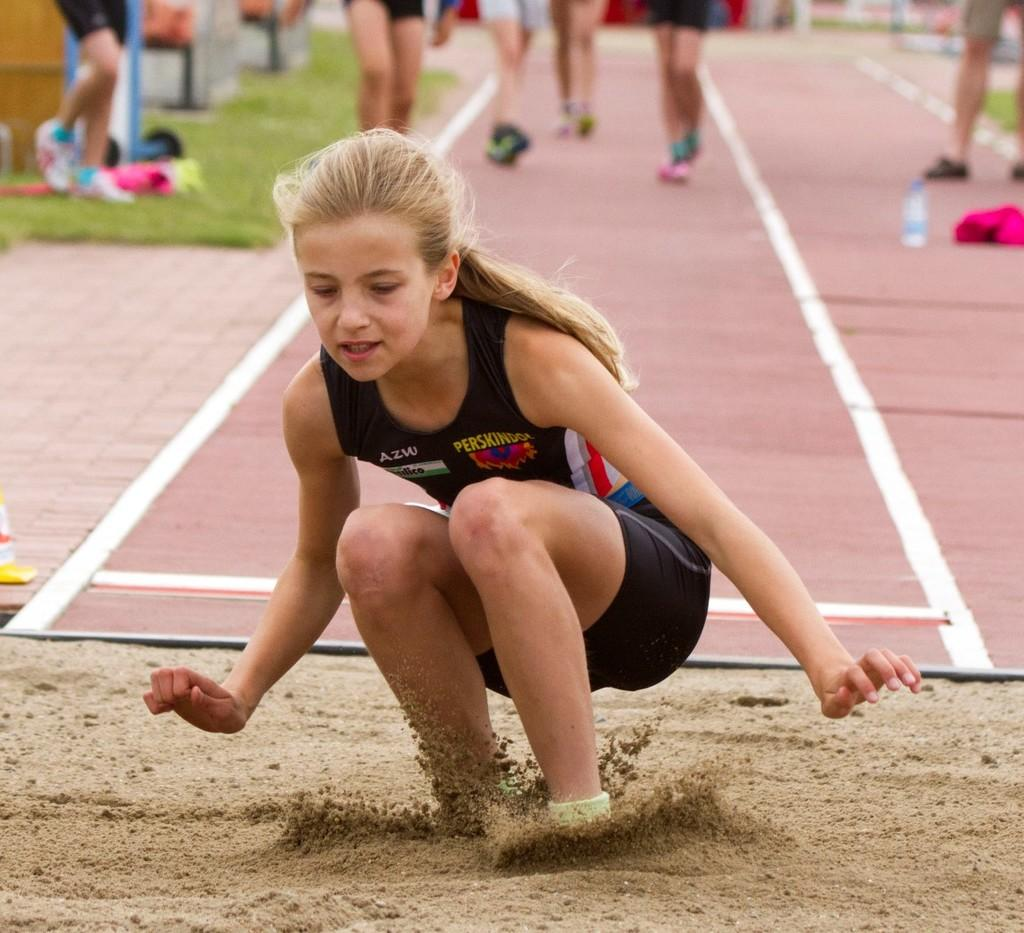What type of surface can be seen in the image? There is green grass and sand visible in the image. What objects can be seen in the image? There is a water bottle and other unspecified objects in the image. What is the position of the girl in the image? There is a girl in a squat position in the image. What is the background of the image? People's legs are visible in the background of the image. What is the floor like in the image? There is a floor in the image. Where is the dock located in the image? There is no dock present in the image. What type of shoes is the minister wearing in the image? There is no minister present in the image. 